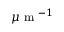<formula> <loc_0><loc_0><loc_500><loc_500>\mu m ^ { - 1 }</formula> 